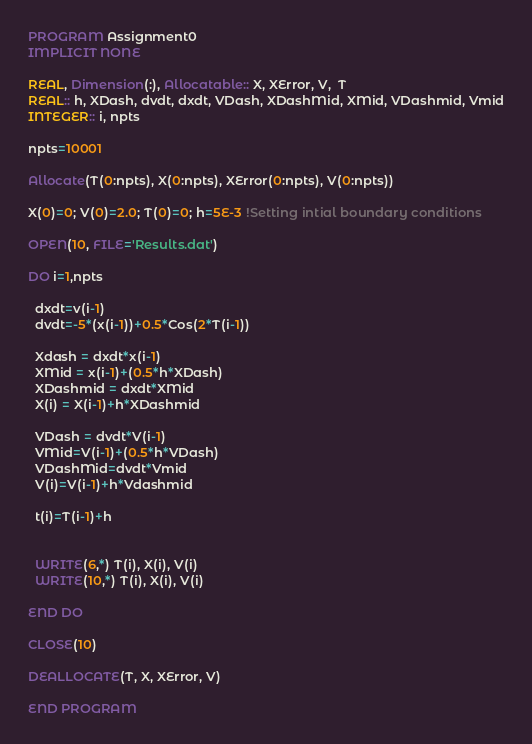Convert code to text. <code><loc_0><loc_0><loc_500><loc_500><_FORTRAN_>PROGRAM Assignment0
IMPLICIT NONE

REAL, Dimension(:), Allocatable:: X, XError, V,  T 
REAL:: h, XDash, dvdt, dxdt, VDash, XDashMid, XMid, VDashmid, Vmid
INTEGER:: i, npts

npts=10001

Allocate(T(0:npts), X(0:npts), XError(0:npts), V(0:npts))

X(0)=0; V(0)=2.0; T(0)=0; h=5E-3 !Setting intial boundary conditions

OPEN(10, FILE='Results.dat')

DO i=1,npts  
  
  dxdt=v(i-1)
  dvdt=-5*(x(i-1))+0.5*Cos(2*T(i-1))
  
  Xdash = dxdt*x(i-1)
  XMid = x(i-1)+(0.5*h*XDash)
  XDashmid = dxdt*XMid
  X(i) = X(i-1)+h*XDashmid 

  VDash = dvdt*V(i-1)
  VMid=V(i-1)+(0.5*h*VDash)
  VDashMid=dvdt*Vmid
  V(i)=V(i-1)+h*Vdashmid

  t(i)=T(i-1)+h


  WRITE(6,*) T(i), X(i), V(i)
  WRITE(10,*) T(i), X(i), V(i)

END DO

CLOSE(10)

DEALLOCATE(T, X, XError, V)

END PROGRAM 



</code> 